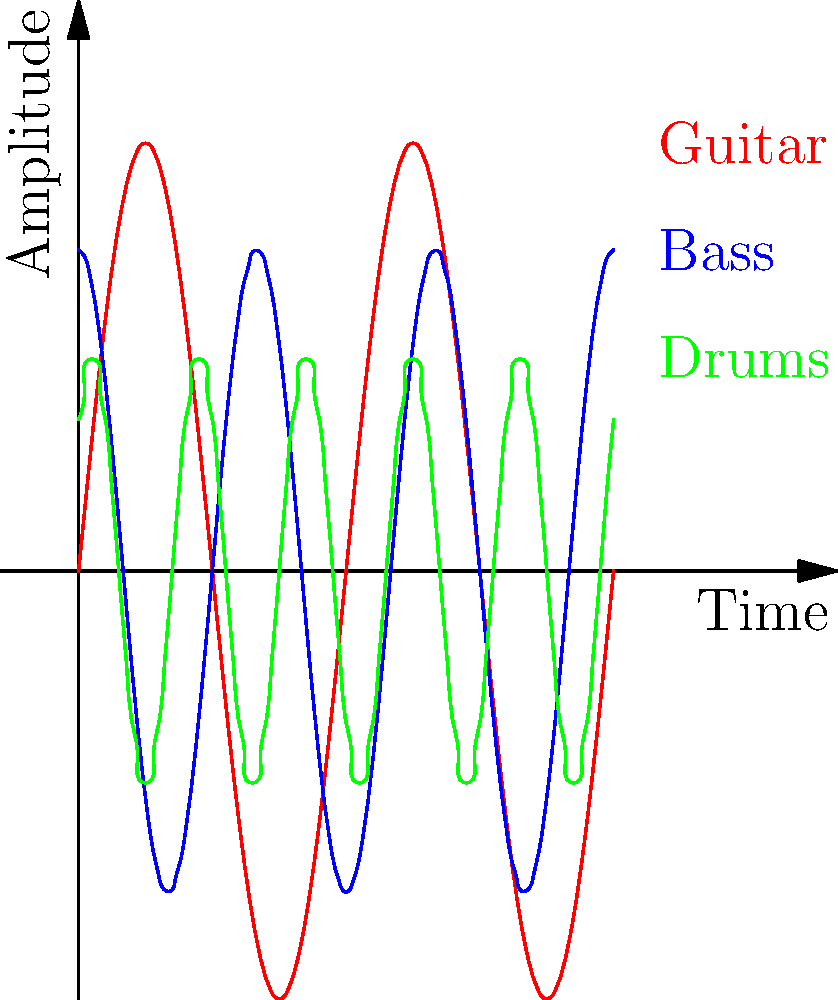As a drummer with a keen ear for indie music, analyze the waveforms shown in the graph. Which instrument is represented by the green waveform, and how does its frequency compare to the others? To answer this question, let's analyze the waveforms step-by-step:

1. The graph shows three waveforms in different colors: red, blue, and green.

2. Each waveform represents a different instrument used in indie music.

3. The x-axis represents time, and the y-axis represents amplitude (loudness).

4. Frequency is represented by how close together the peaks and troughs are - the closer they are, the higher the frequency.

5. Comparing the waveforms:
   - Red: Has the lowest frequency (fewest peaks and troughs)
   - Blue: Has a medium frequency
   - Green: Has the highest frequency (most peaks and troughs)

6. In indie music, typically:
   - Guitars have a mid-range frequency
   - Bass guitars have a low frequency
   - Drums, especially cymbals and hi-hats, have higher frequencies

7. The legend indicates that the green waveform represents drums.

8. The green waveform has the highest frequency among the three, which aligns with the characteristic of drum sounds, especially cymbals and hi-hats in indie music.

Therefore, the green waveform represents drums, and it has the highest frequency compared to the other instruments shown.
Answer: Drums; highest frequency 